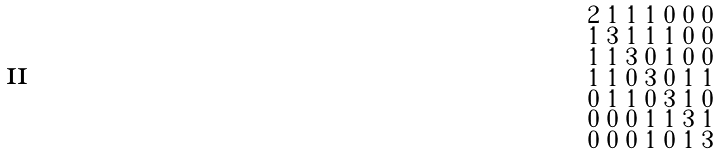Convert formula to latex. <formula><loc_0><loc_0><loc_500><loc_500>\begin{smallmatrix} 2 & 1 & 1 & 1 & 0 & 0 & 0 \\ 1 & 3 & 1 & 1 & 1 & 0 & 0 \\ 1 & 1 & 3 & 0 & 1 & 0 & 0 \\ 1 & 1 & 0 & 3 & 0 & 1 & 1 \\ 0 & 1 & 1 & 0 & 3 & 1 & 0 \\ 0 & 0 & 0 & 1 & 1 & 3 & 1 \\ 0 & 0 & 0 & 1 & 0 & 1 & 3 \end{smallmatrix}</formula> 